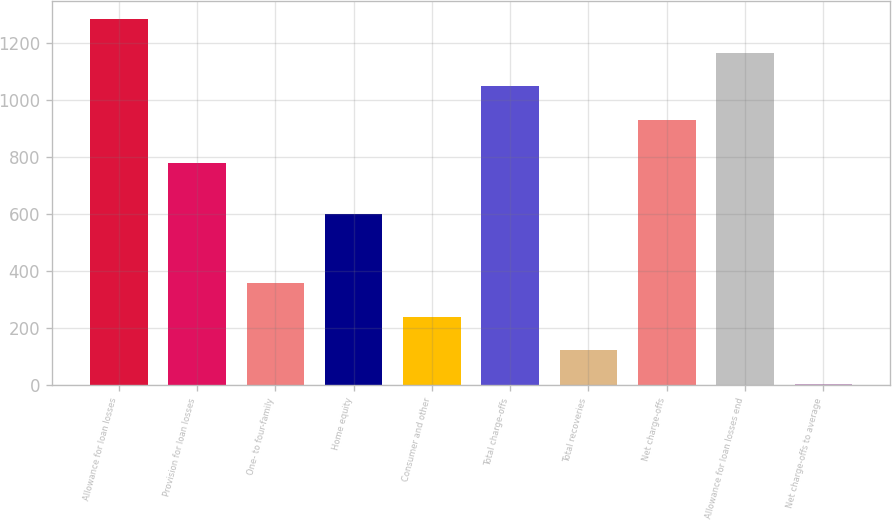Convert chart. <chart><loc_0><loc_0><loc_500><loc_500><bar_chart><fcel>Allowance for loan losses<fcel>Provision for loan losses<fcel>One- to four-family<fcel>Home equity<fcel>Consumer and other<fcel>Total charge-offs<fcel>Total recoveries<fcel>Net charge-offs<fcel>Allowance for loan losses end<fcel>Net charge-offs to average<nl><fcel>1284.37<fcel>779<fcel>358.47<fcel>600<fcel>240.68<fcel>1048.79<fcel>122.89<fcel>931<fcel>1166.58<fcel>5.1<nl></chart> 